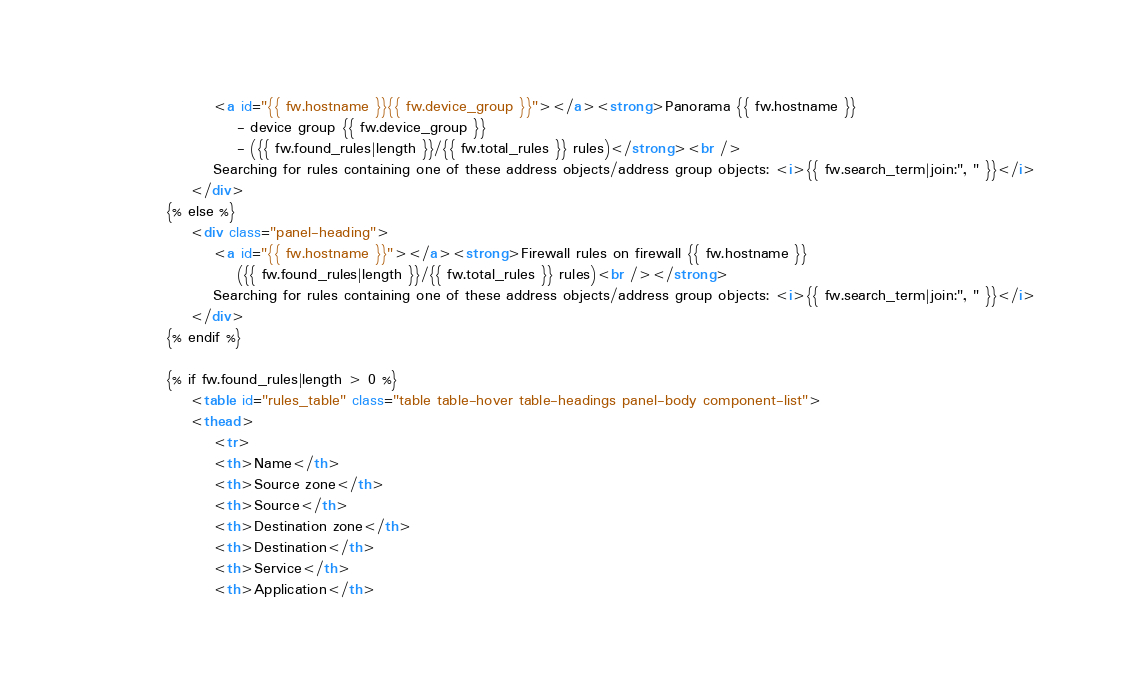<code> <loc_0><loc_0><loc_500><loc_500><_HTML_>				    <a id="{{ fw.hostname }}{{ fw.device_group }}"></a><strong>Panorama {{ fw.hostname }} 
					    - device group {{ fw.device_group }} 
					    - ({{ fw.found_rules|length }}/{{ fw.total_rules }} rules)</strong><br />
				    Searching for rules containing one of these address objects/address group objects: <i>{{ fw.search_term|join:", " }}</i>
			    </div>
			{% else %}
			    <div class="panel-heading">
				    <a id="{{ fw.hostname }}"></a><strong>Firewall rules on firewall {{ fw.hostname }} 
					    ({{ fw.found_rules|length }}/{{ fw.total_rules }} rules)<br /></strong>
				    Searching for rules containing one of these address objects/address group objects: <i>{{ fw.search_term|join:", " }}</i>
			    </div>
			{% endif %}

			{% if fw.found_rules|length > 0 %}
			    <table id="rules_table" class="table table-hover table-headings panel-body component-list">
				<thead>
				    <tr>
					<th>Name</th>
					<th>Source zone</th>
					<th>Source</th>
					<th>Destination zone</th>
					<th>Destination</th>
					<th>Service</th>
					<th>Application</th></code> 